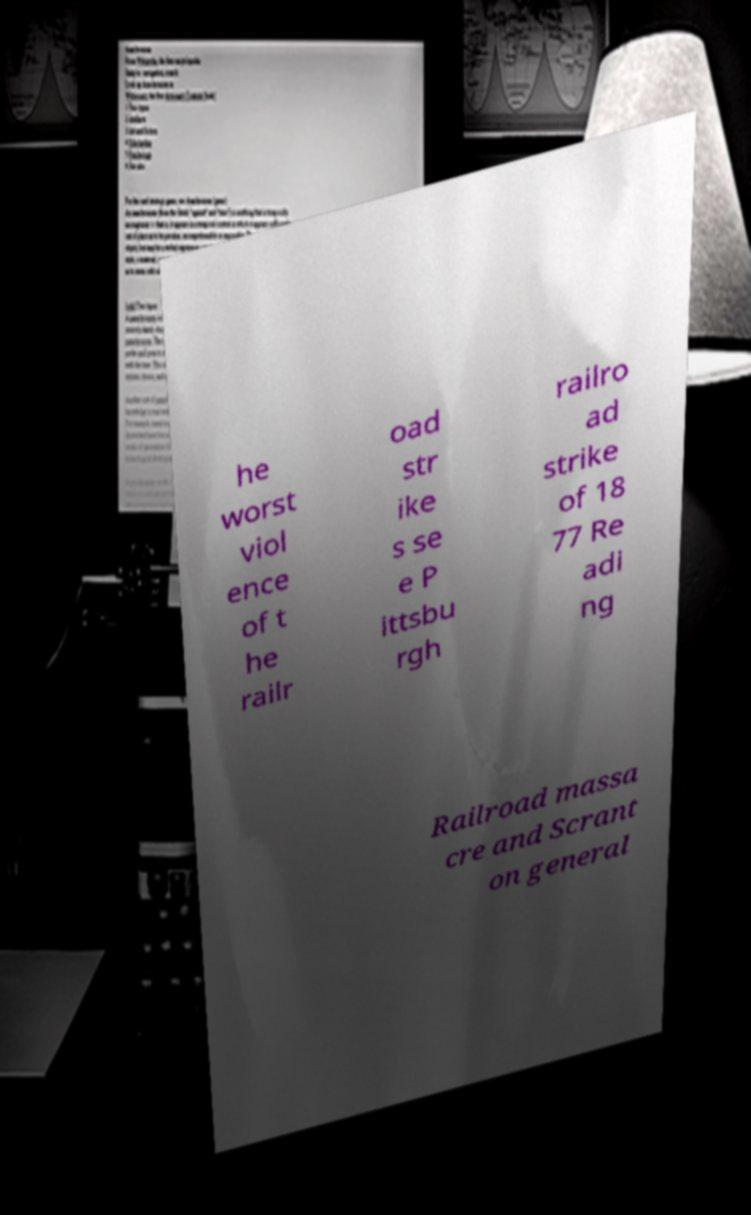Could you extract and type out the text from this image? he worst viol ence of t he railr oad str ike s se e P ittsbu rgh railro ad strike of 18 77 Re adi ng Railroad massa cre and Scrant on general 